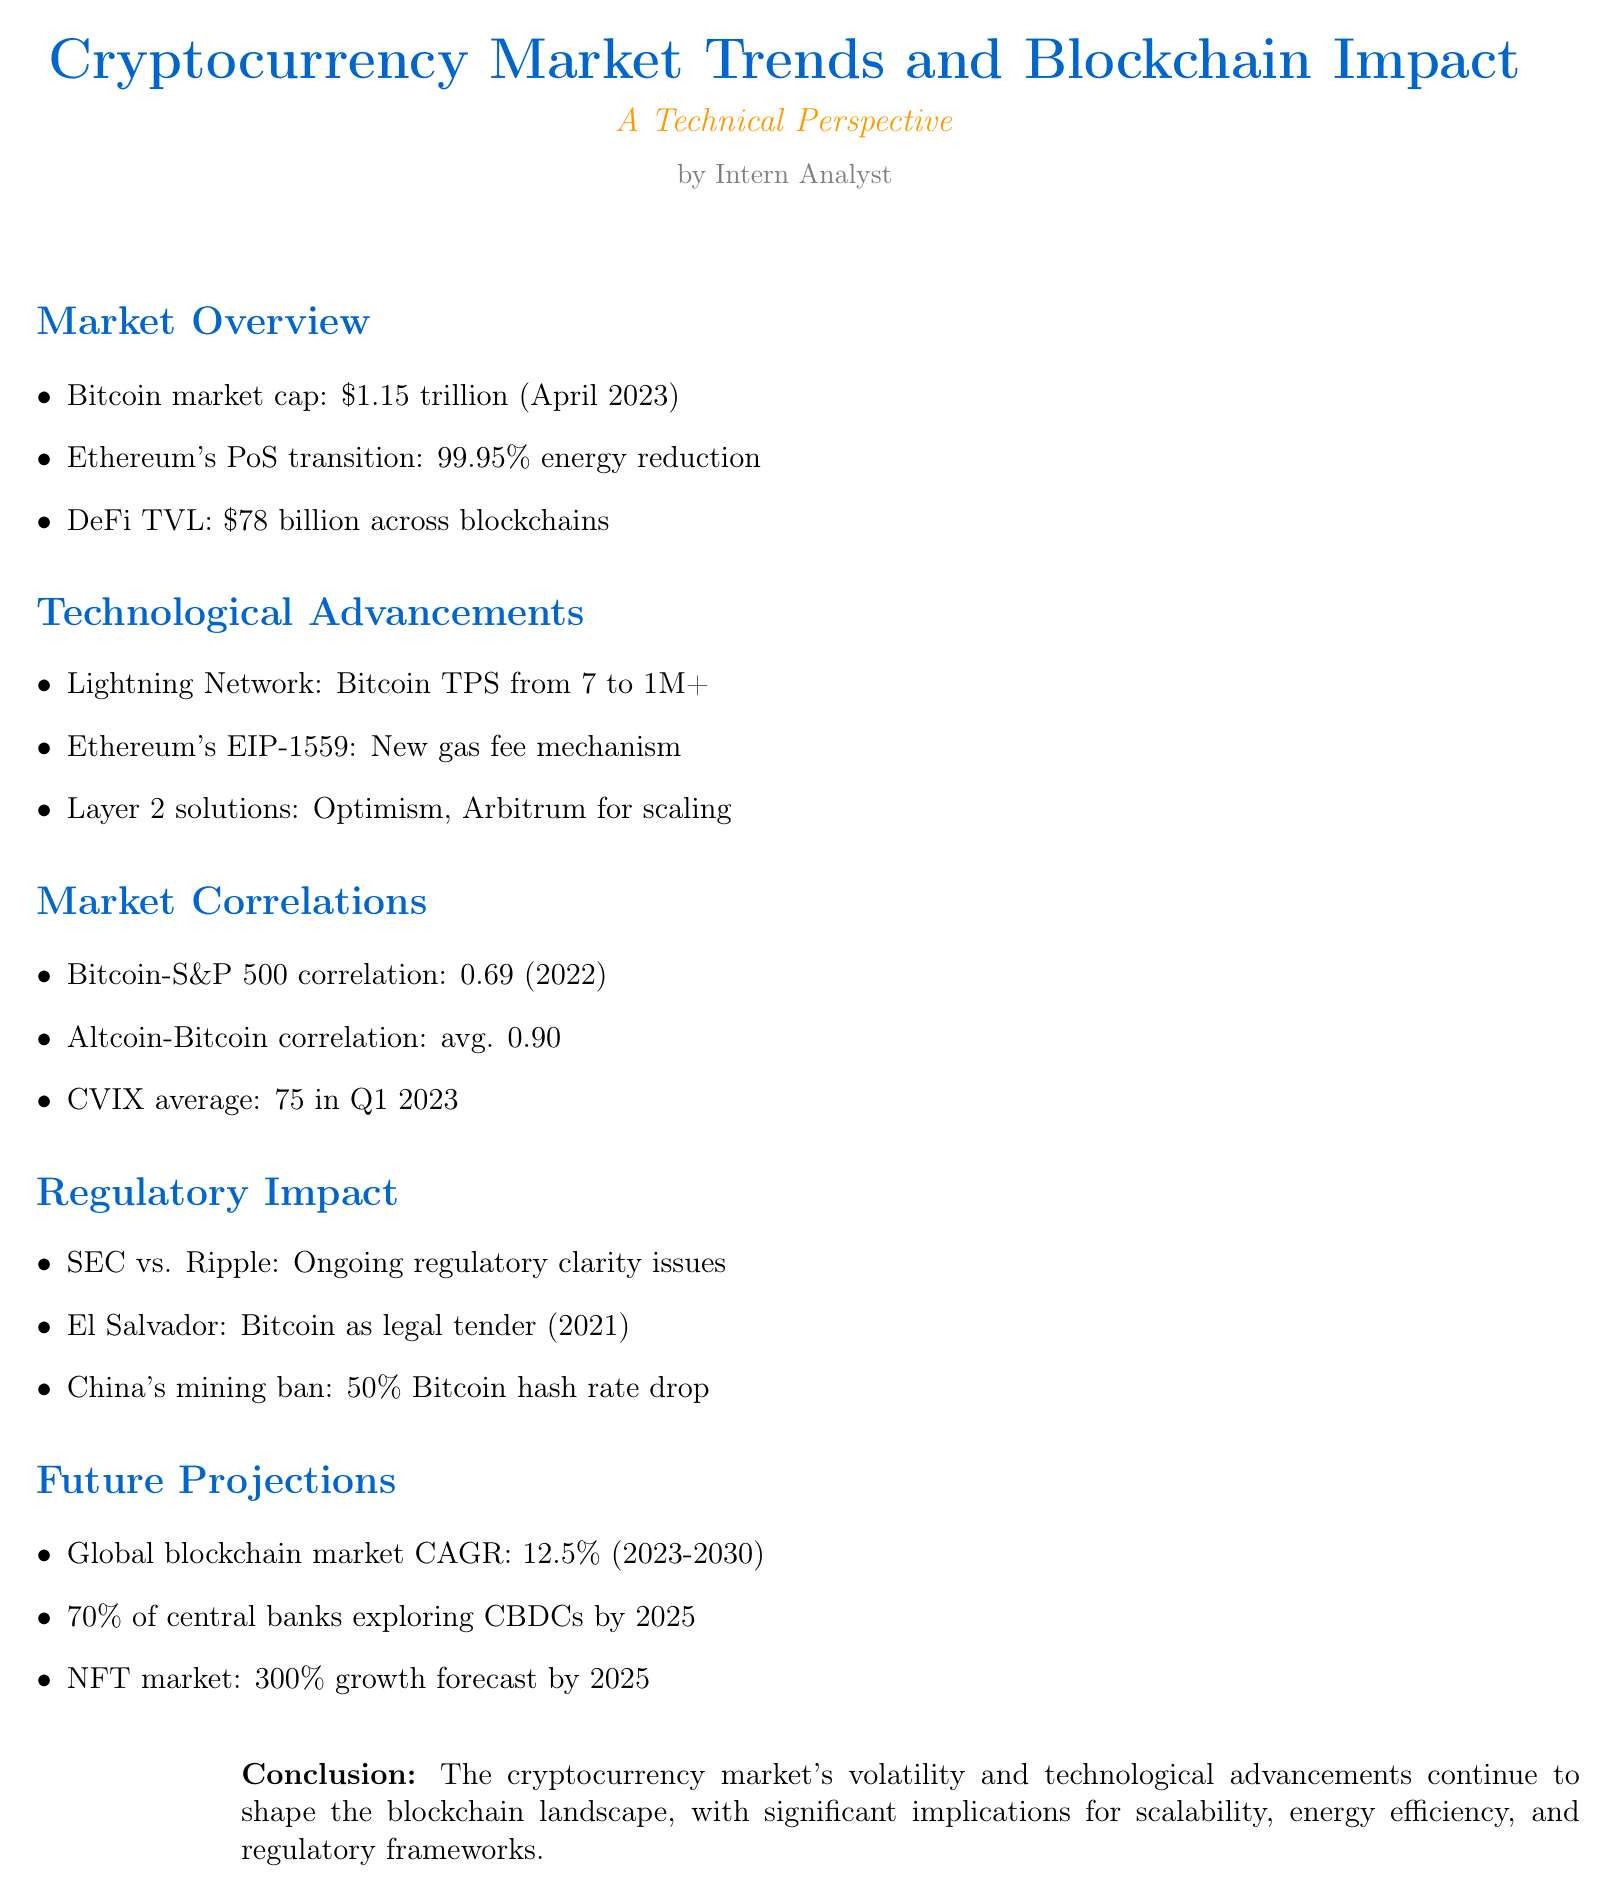What is the Bitcoin market cap as of April 2023? The document states that Bitcoin's market cap is $1.15 trillion as of April 2023.
Answer: $1.15 trillion How much did Ethereum's transition to Proof-of-Stake reduce energy consumption? The document indicates that Ethereum's transition to Proof-of-Stake reduced energy consumption by 99.95%.
Answer: 99.95% What is the total value locked (TVL) in DeFi as mentioned in the report? The report mentions that the DeFi Total Value Locked (TVL) is $78 billion across various blockchains.
Answer: $78 billion What is the projected CAGR for the global blockchain market from 2023 to 2030? The document states that the projected CAGR of the global blockchain market from 2023 to 2030 is 12.5%.
Answer: 12.5% What correlation coefficient did Bitcoin have with the S&P 500 in 2022? According to the document, the correlation coefficient between Bitcoin and the S&P 500 was 0.69 in 2022.
Answer: 0.69 Which layer 2 solutions are mentioned for Ethereum scaling in the report? The report lists Optimism and Arbitrum as layer 2 solutions for Ethereum scaling.
Answer: Optimism and Arbitrum What significant regulatory event is discussed in relation to Ripple (XRP)? The document mentions the SEC's ongoing lawsuit against Ripple (XRP) as a significant regulatory event.
Answer: SEC's ongoing lawsuit against Ripple What percentage of central banks is exploring CBDCs by 2025 according to projections? The report states that an estimated 70% of central banks are exploring CBDCs by 2025.
Answer: 70% What is the document's conclusion regarding the cryptocurrency market's impact? The document concludes that the cryptocurrency market's volatility and technological advancements continue to shape the blockchain landscape.
Answer: Technological advancements 